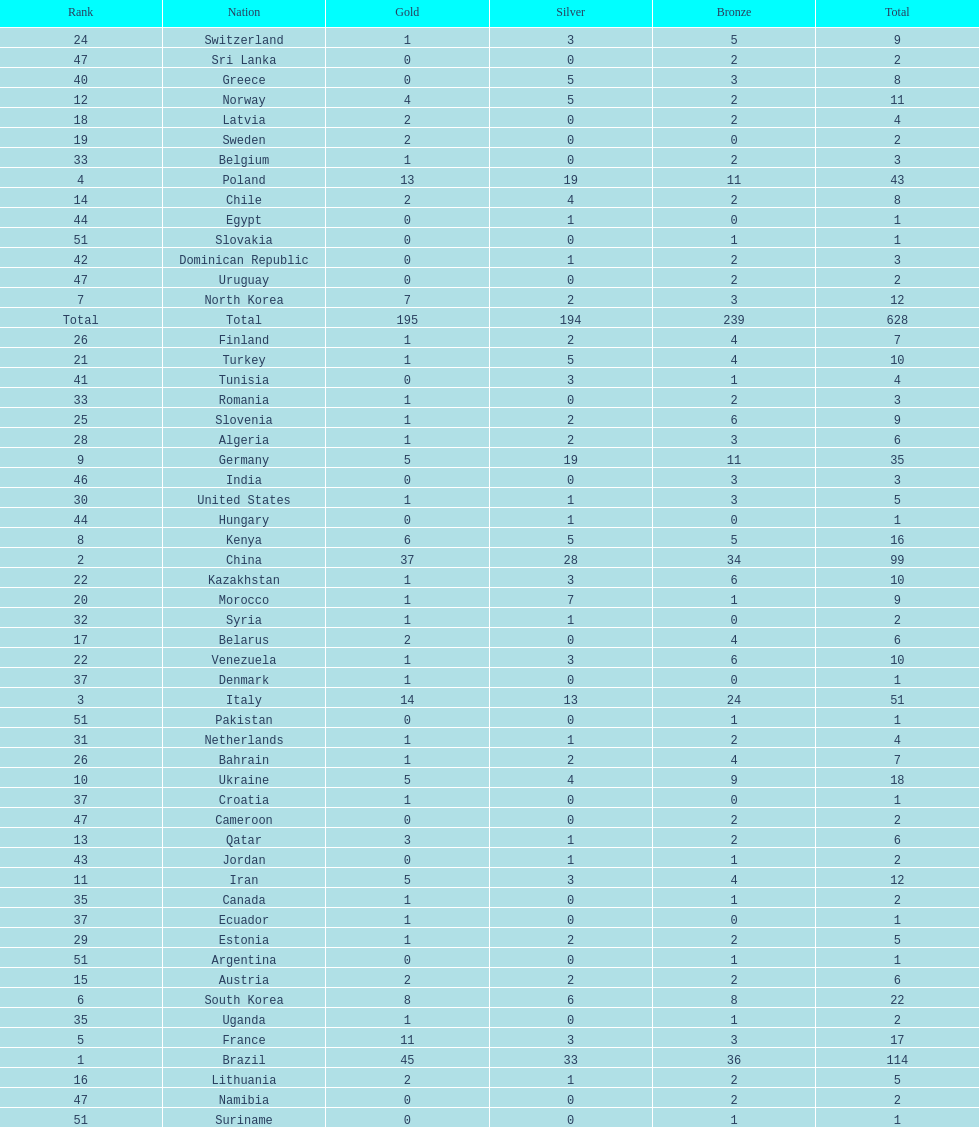How many total medals did norway win? 11. 